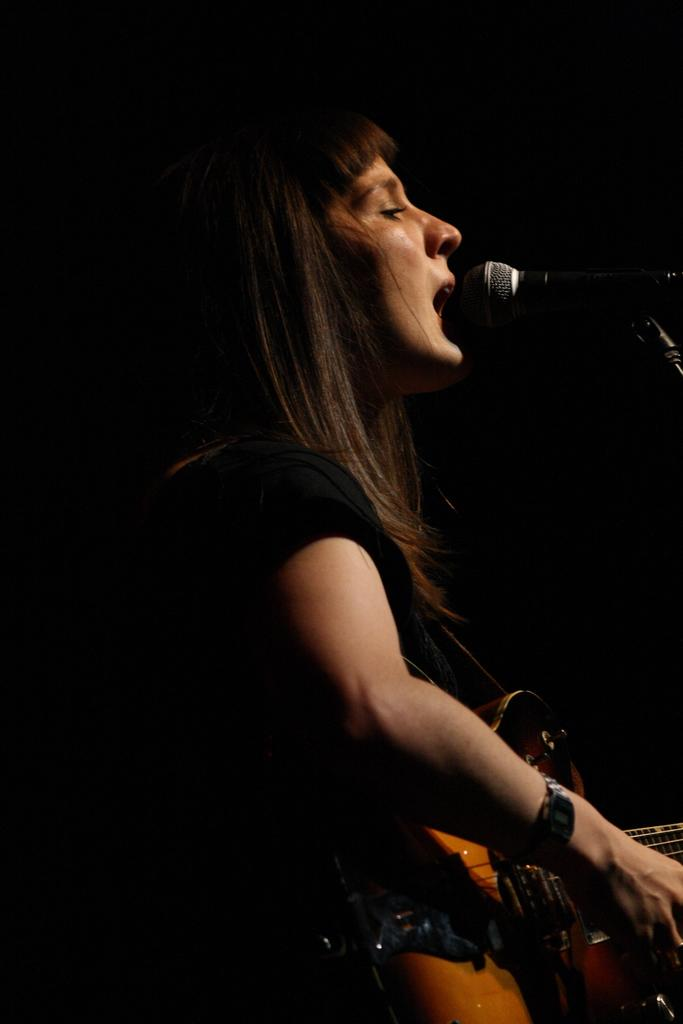Who is the main subject in the image? There is a girl in the image. What is the girl doing in the image? The girl is playing the guitar and singing into a microphone. What type of button is the girl wearing on her shirt in the image? There is no button mentioned or visible in the image; the focus is on the girl playing the guitar and singing into a microphone. 